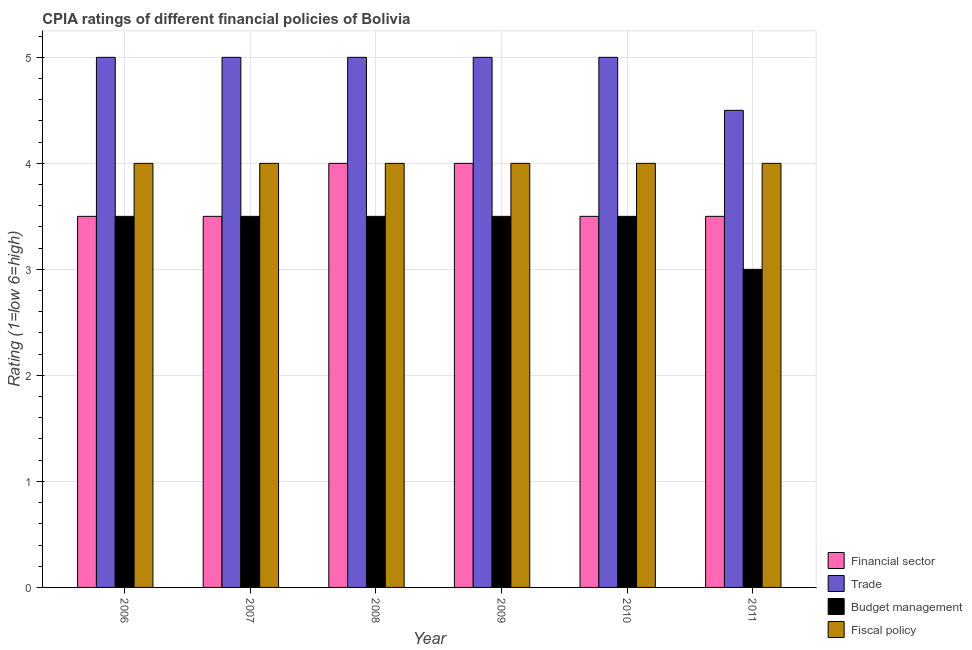Are the number of bars on each tick of the X-axis equal?
Give a very brief answer. Yes. What is the cpia rating of trade in 2007?
Give a very brief answer. 5. Across all years, what is the maximum cpia rating of fiscal policy?
Your response must be concise. 4. Across all years, what is the minimum cpia rating of fiscal policy?
Your response must be concise. 4. What is the total cpia rating of financial sector in the graph?
Give a very brief answer. 22. What is the average cpia rating of budget management per year?
Offer a terse response. 3.42. What is the ratio of the cpia rating of trade in 2008 to that in 2011?
Provide a succinct answer. 1.11. Is the cpia rating of trade in 2006 less than that in 2009?
Your response must be concise. No. Is it the case that in every year, the sum of the cpia rating of trade and cpia rating of budget management is greater than the sum of cpia rating of fiscal policy and cpia rating of financial sector?
Make the answer very short. Yes. What does the 4th bar from the left in 2008 represents?
Keep it short and to the point. Fiscal policy. What does the 1st bar from the right in 2006 represents?
Your answer should be compact. Fiscal policy. Is it the case that in every year, the sum of the cpia rating of financial sector and cpia rating of trade is greater than the cpia rating of budget management?
Ensure brevity in your answer.  Yes. How many bars are there?
Your answer should be compact. 24. Are all the bars in the graph horizontal?
Ensure brevity in your answer.  No. How many years are there in the graph?
Your answer should be compact. 6. What is the difference between two consecutive major ticks on the Y-axis?
Provide a short and direct response. 1. Does the graph contain any zero values?
Offer a terse response. No. Does the graph contain grids?
Ensure brevity in your answer.  Yes. How many legend labels are there?
Your answer should be compact. 4. How are the legend labels stacked?
Provide a succinct answer. Vertical. What is the title of the graph?
Provide a short and direct response. CPIA ratings of different financial policies of Bolivia. Does "Burnt food" appear as one of the legend labels in the graph?
Ensure brevity in your answer.  No. What is the label or title of the Y-axis?
Provide a short and direct response. Rating (1=low 6=high). What is the Rating (1=low 6=high) of Trade in 2006?
Your response must be concise. 5. What is the Rating (1=low 6=high) of Fiscal policy in 2006?
Provide a succinct answer. 4. What is the Rating (1=low 6=high) of Trade in 2007?
Make the answer very short. 5. What is the Rating (1=low 6=high) in Budget management in 2007?
Your answer should be compact. 3.5. What is the Rating (1=low 6=high) in Fiscal policy in 2007?
Ensure brevity in your answer.  4. What is the Rating (1=low 6=high) in Financial sector in 2008?
Your response must be concise. 4. What is the Rating (1=low 6=high) of Trade in 2008?
Your answer should be very brief. 5. What is the Rating (1=low 6=high) of Fiscal policy in 2008?
Provide a succinct answer. 4. What is the Rating (1=low 6=high) in Trade in 2010?
Your answer should be compact. 5. What is the Rating (1=low 6=high) of Budget management in 2010?
Offer a very short reply. 3.5. What is the Rating (1=low 6=high) in Fiscal policy in 2010?
Your answer should be compact. 4. What is the Rating (1=low 6=high) of Financial sector in 2011?
Your answer should be compact. 3.5. What is the Rating (1=low 6=high) of Trade in 2011?
Provide a short and direct response. 4.5. What is the Rating (1=low 6=high) of Budget management in 2011?
Your response must be concise. 3. What is the Rating (1=low 6=high) in Fiscal policy in 2011?
Your response must be concise. 4. Across all years, what is the maximum Rating (1=low 6=high) of Budget management?
Make the answer very short. 3.5. Across all years, what is the minimum Rating (1=low 6=high) in Budget management?
Keep it short and to the point. 3. Across all years, what is the minimum Rating (1=low 6=high) in Fiscal policy?
Keep it short and to the point. 4. What is the total Rating (1=low 6=high) of Trade in the graph?
Provide a short and direct response. 29.5. What is the difference between the Rating (1=low 6=high) in Trade in 2006 and that in 2008?
Give a very brief answer. 0. What is the difference between the Rating (1=low 6=high) in Fiscal policy in 2006 and that in 2008?
Your answer should be very brief. 0. What is the difference between the Rating (1=low 6=high) of Budget management in 2006 and that in 2009?
Give a very brief answer. 0. What is the difference between the Rating (1=low 6=high) in Fiscal policy in 2006 and that in 2009?
Ensure brevity in your answer.  0. What is the difference between the Rating (1=low 6=high) of Financial sector in 2006 and that in 2010?
Offer a very short reply. 0. What is the difference between the Rating (1=low 6=high) in Budget management in 2006 and that in 2010?
Ensure brevity in your answer.  0. What is the difference between the Rating (1=low 6=high) in Fiscal policy in 2006 and that in 2010?
Provide a short and direct response. 0. What is the difference between the Rating (1=low 6=high) in Financial sector in 2006 and that in 2011?
Your answer should be compact. 0. What is the difference between the Rating (1=low 6=high) in Fiscal policy in 2006 and that in 2011?
Offer a very short reply. 0. What is the difference between the Rating (1=low 6=high) in Budget management in 2007 and that in 2008?
Provide a succinct answer. 0. What is the difference between the Rating (1=low 6=high) of Fiscal policy in 2007 and that in 2008?
Make the answer very short. 0. What is the difference between the Rating (1=low 6=high) of Financial sector in 2007 and that in 2009?
Provide a succinct answer. -0.5. What is the difference between the Rating (1=low 6=high) in Fiscal policy in 2007 and that in 2009?
Give a very brief answer. 0. What is the difference between the Rating (1=low 6=high) of Fiscal policy in 2007 and that in 2010?
Keep it short and to the point. 0. What is the difference between the Rating (1=low 6=high) of Trade in 2007 and that in 2011?
Offer a terse response. 0.5. What is the difference between the Rating (1=low 6=high) of Budget management in 2007 and that in 2011?
Offer a terse response. 0.5. What is the difference between the Rating (1=low 6=high) of Fiscal policy in 2007 and that in 2011?
Provide a succinct answer. 0. What is the difference between the Rating (1=low 6=high) of Trade in 2008 and that in 2009?
Ensure brevity in your answer.  0. What is the difference between the Rating (1=low 6=high) in Financial sector in 2008 and that in 2010?
Give a very brief answer. 0.5. What is the difference between the Rating (1=low 6=high) of Budget management in 2008 and that in 2010?
Offer a terse response. 0. What is the difference between the Rating (1=low 6=high) in Fiscal policy in 2008 and that in 2010?
Keep it short and to the point. 0. What is the difference between the Rating (1=low 6=high) in Financial sector in 2008 and that in 2011?
Provide a succinct answer. 0.5. What is the difference between the Rating (1=low 6=high) in Financial sector in 2009 and that in 2011?
Provide a succinct answer. 0.5. What is the difference between the Rating (1=low 6=high) of Budget management in 2009 and that in 2011?
Your response must be concise. 0.5. What is the difference between the Rating (1=low 6=high) of Fiscal policy in 2009 and that in 2011?
Provide a succinct answer. 0. What is the difference between the Rating (1=low 6=high) in Financial sector in 2010 and that in 2011?
Give a very brief answer. 0. What is the difference between the Rating (1=low 6=high) in Trade in 2010 and that in 2011?
Offer a terse response. 0.5. What is the difference between the Rating (1=low 6=high) in Budget management in 2010 and that in 2011?
Offer a terse response. 0.5. What is the difference between the Rating (1=low 6=high) in Financial sector in 2006 and the Rating (1=low 6=high) in Budget management in 2007?
Ensure brevity in your answer.  0. What is the difference between the Rating (1=low 6=high) of Financial sector in 2006 and the Rating (1=low 6=high) of Fiscal policy in 2007?
Give a very brief answer. -0.5. What is the difference between the Rating (1=low 6=high) of Trade in 2006 and the Rating (1=low 6=high) of Budget management in 2007?
Provide a short and direct response. 1.5. What is the difference between the Rating (1=low 6=high) in Budget management in 2006 and the Rating (1=low 6=high) in Fiscal policy in 2007?
Offer a very short reply. -0.5. What is the difference between the Rating (1=low 6=high) in Trade in 2006 and the Rating (1=low 6=high) in Fiscal policy in 2008?
Keep it short and to the point. 1. What is the difference between the Rating (1=low 6=high) of Budget management in 2006 and the Rating (1=low 6=high) of Fiscal policy in 2008?
Provide a short and direct response. -0.5. What is the difference between the Rating (1=low 6=high) in Financial sector in 2006 and the Rating (1=low 6=high) in Trade in 2009?
Your answer should be very brief. -1.5. What is the difference between the Rating (1=low 6=high) in Financial sector in 2006 and the Rating (1=low 6=high) in Budget management in 2009?
Your response must be concise. 0. What is the difference between the Rating (1=low 6=high) of Financial sector in 2006 and the Rating (1=low 6=high) of Fiscal policy in 2009?
Give a very brief answer. -0.5. What is the difference between the Rating (1=low 6=high) in Trade in 2006 and the Rating (1=low 6=high) in Fiscal policy in 2009?
Give a very brief answer. 1. What is the difference between the Rating (1=low 6=high) of Budget management in 2006 and the Rating (1=low 6=high) of Fiscal policy in 2009?
Your answer should be compact. -0.5. What is the difference between the Rating (1=low 6=high) of Financial sector in 2006 and the Rating (1=low 6=high) of Trade in 2010?
Provide a succinct answer. -1.5. What is the difference between the Rating (1=low 6=high) in Financial sector in 2006 and the Rating (1=low 6=high) in Fiscal policy in 2010?
Give a very brief answer. -0.5. What is the difference between the Rating (1=low 6=high) of Trade in 2006 and the Rating (1=low 6=high) of Budget management in 2010?
Offer a very short reply. 1.5. What is the difference between the Rating (1=low 6=high) in Trade in 2006 and the Rating (1=low 6=high) in Fiscal policy in 2010?
Ensure brevity in your answer.  1. What is the difference between the Rating (1=low 6=high) of Financial sector in 2006 and the Rating (1=low 6=high) of Trade in 2011?
Offer a terse response. -1. What is the difference between the Rating (1=low 6=high) in Financial sector in 2006 and the Rating (1=low 6=high) in Budget management in 2011?
Give a very brief answer. 0.5. What is the difference between the Rating (1=low 6=high) of Financial sector in 2007 and the Rating (1=low 6=high) of Budget management in 2008?
Make the answer very short. 0. What is the difference between the Rating (1=low 6=high) of Trade in 2007 and the Rating (1=low 6=high) of Budget management in 2008?
Offer a very short reply. 1.5. What is the difference between the Rating (1=low 6=high) in Trade in 2007 and the Rating (1=low 6=high) in Fiscal policy in 2008?
Give a very brief answer. 1. What is the difference between the Rating (1=low 6=high) of Budget management in 2007 and the Rating (1=low 6=high) of Fiscal policy in 2008?
Offer a very short reply. -0.5. What is the difference between the Rating (1=low 6=high) in Financial sector in 2007 and the Rating (1=low 6=high) in Trade in 2009?
Provide a short and direct response. -1.5. What is the difference between the Rating (1=low 6=high) of Financial sector in 2007 and the Rating (1=low 6=high) of Budget management in 2009?
Your answer should be very brief. 0. What is the difference between the Rating (1=low 6=high) in Financial sector in 2007 and the Rating (1=low 6=high) in Fiscal policy in 2009?
Keep it short and to the point. -0.5. What is the difference between the Rating (1=low 6=high) of Budget management in 2007 and the Rating (1=low 6=high) of Fiscal policy in 2009?
Ensure brevity in your answer.  -0.5. What is the difference between the Rating (1=low 6=high) in Financial sector in 2007 and the Rating (1=low 6=high) in Budget management in 2010?
Offer a very short reply. 0. What is the difference between the Rating (1=low 6=high) of Financial sector in 2007 and the Rating (1=low 6=high) of Trade in 2011?
Give a very brief answer. -1. What is the difference between the Rating (1=low 6=high) of Trade in 2007 and the Rating (1=low 6=high) of Budget management in 2011?
Ensure brevity in your answer.  2. What is the difference between the Rating (1=low 6=high) in Budget management in 2007 and the Rating (1=low 6=high) in Fiscal policy in 2011?
Your answer should be compact. -0.5. What is the difference between the Rating (1=low 6=high) of Financial sector in 2008 and the Rating (1=low 6=high) of Fiscal policy in 2009?
Your answer should be very brief. 0. What is the difference between the Rating (1=low 6=high) of Trade in 2008 and the Rating (1=low 6=high) of Fiscal policy in 2009?
Your response must be concise. 1. What is the difference between the Rating (1=low 6=high) of Trade in 2008 and the Rating (1=low 6=high) of Budget management in 2010?
Your response must be concise. 1.5. What is the difference between the Rating (1=low 6=high) of Budget management in 2008 and the Rating (1=low 6=high) of Fiscal policy in 2010?
Your answer should be compact. -0.5. What is the difference between the Rating (1=low 6=high) of Financial sector in 2008 and the Rating (1=low 6=high) of Trade in 2011?
Provide a succinct answer. -0.5. What is the difference between the Rating (1=low 6=high) of Financial sector in 2008 and the Rating (1=low 6=high) of Budget management in 2011?
Your response must be concise. 1. What is the difference between the Rating (1=low 6=high) of Trade in 2008 and the Rating (1=low 6=high) of Budget management in 2011?
Make the answer very short. 2. What is the difference between the Rating (1=low 6=high) of Trade in 2008 and the Rating (1=low 6=high) of Fiscal policy in 2011?
Offer a terse response. 1. What is the difference between the Rating (1=low 6=high) of Trade in 2009 and the Rating (1=low 6=high) of Budget management in 2010?
Provide a short and direct response. 1.5. What is the difference between the Rating (1=low 6=high) in Budget management in 2009 and the Rating (1=low 6=high) in Fiscal policy in 2010?
Keep it short and to the point. -0.5. What is the difference between the Rating (1=low 6=high) of Financial sector in 2009 and the Rating (1=low 6=high) of Budget management in 2011?
Ensure brevity in your answer.  1. What is the difference between the Rating (1=low 6=high) in Financial sector in 2009 and the Rating (1=low 6=high) in Fiscal policy in 2011?
Your answer should be very brief. 0. What is the difference between the Rating (1=low 6=high) in Financial sector in 2010 and the Rating (1=low 6=high) in Budget management in 2011?
Offer a terse response. 0.5. What is the difference between the Rating (1=low 6=high) of Financial sector in 2010 and the Rating (1=low 6=high) of Fiscal policy in 2011?
Your answer should be compact. -0.5. What is the difference between the Rating (1=low 6=high) in Trade in 2010 and the Rating (1=low 6=high) in Fiscal policy in 2011?
Your response must be concise. 1. What is the difference between the Rating (1=low 6=high) of Budget management in 2010 and the Rating (1=low 6=high) of Fiscal policy in 2011?
Provide a succinct answer. -0.5. What is the average Rating (1=low 6=high) in Financial sector per year?
Offer a terse response. 3.67. What is the average Rating (1=low 6=high) of Trade per year?
Give a very brief answer. 4.92. What is the average Rating (1=low 6=high) of Budget management per year?
Keep it short and to the point. 3.42. What is the average Rating (1=low 6=high) of Fiscal policy per year?
Offer a terse response. 4. In the year 2006, what is the difference between the Rating (1=low 6=high) in Financial sector and Rating (1=low 6=high) in Trade?
Keep it short and to the point. -1.5. In the year 2006, what is the difference between the Rating (1=low 6=high) of Financial sector and Rating (1=low 6=high) of Budget management?
Keep it short and to the point. 0. In the year 2006, what is the difference between the Rating (1=low 6=high) of Trade and Rating (1=low 6=high) of Budget management?
Provide a succinct answer. 1.5. In the year 2006, what is the difference between the Rating (1=low 6=high) of Trade and Rating (1=low 6=high) of Fiscal policy?
Offer a very short reply. 1. In the year 2006, what is the difference between the Rating (1=low 6=high) in Budget management and Rating (1=low 6=high) in Fiscal policy?
Provide a short and direct response. -0.5. In the year 2007, what is the difference between the Rating (1=low 6=high) in Financial sector and Rating (1=low 6=high) in Fiscal policy?
Offer a very short reply. -0.5. In the year 2008, what is the difference between the Rating (1=low 6=high) in Financial sector and Rating (1=low 6=high) in Trade?
Ensure brevity in your answer.  -1. In the year 2008, what is the difference between the Rating (1=low 6=high) of Financial sector and Rating (1=low 6=high) of Budget management?
Give a very brief answer. 0.5. In the year 2008, what is the difference between the Rating (1=low 6=high) in Financial sector and Rating (1=low 6=high) in Fiscal policy?
Your response must be concise. 0. In the year 2008, what is the difference between the Rating (1=low 6=high) in Trade and Rating (1=low 6=high) in Budget management?
Your response must be concise. 1.5. In the year 2008, what is the difference between the Rating (1=low 6=high) of Trade and Rating (1=low 6=high) of Fiscal policy?
Ensure brevity in your answer.  1. In the year 2009, what is the difference between the Rating (1=low 6=high) of Trade and Rating (1=low 6=high) of Budget management?
Make the answer very short. 1.5. In the year 2009, what is the difference between the Rating (1=low 6=high) in Budget management and Rating (1=low 6=high) in Fiscal policy?
Your answer should be compact. -0.5. In the year 2010, what is the difference between the Rating (1=low 6=high) in Trade and Rating (1=low 6=high) in Budget management?
Your response must be concise. 1.5. In the year 2010, what is the difference between the Rating (1=low 6=high) in Trade and Rating (1=low 6=high) in Fiscal policy?
Provide a short and direct response. 1. In the year 2010, what is the difference between the Rating (1=low 6=high) of Budget management and Rating (1=low 6=high) of Fiscal policy?
Make the answer very short. -0.5. In the year 2011, what is the difference between the Rating (1=low 6=high) of Trade and Rating (1=low 6=high) of Fiscal policy?
Your answer should be compact. 0.5. In the year 2011, what is the difference between the Rating (1=low 6=high) of Budget management and Rating (1=low 6=high) of Fiscal policy?
Make the answer very short. -1. What is the ratio of the Rating (1=low 6=high) in Financial sector in 2006 to that in 2007?
Offer a terse response. 1. What is the ratio of the Rating (1=low 6=high) in Trade in 2006 to that in 2007?
Offer a terse response. 1. What is the ratio of the Rating (1=low 6=high) of Budget management in 2006 to that in 2007?
Ensure brevity in your answer.  1. What is the ratio of the Rating (1=low 6=high) of Financial sector in 2006 to that in 2008?
Ensure brevity in your answer.  0.88. What is the ratio of the Rating (1=low 6=high) in Trade in 2006 to that in 2008?
Give a very brief answer. 1. What is the ratio of the Rating (1=low 6=high) of Fiscal policy in 2006 to that in 2008?
Provide a short and direct response. 1. What is the ratio of the Rating (1=low 6=high) of Financial sector in 2006 to that in 2009?
Your answer should be compact. 0.88. What is the ratio of the Rating (1=low 6=high) of Budget management in 2006 to that in 2009?
Your answer should be compact. 1. What is the ratio of the Rating (1=low 6=high) in Budget management in 2006 to that in 2010?
Provide a succinct answer. 1. What is the ratio of the Rating (1=low 6=high) of Financial sector in 2006 to that in 2011?
Your answer should be compact. 1. What is the ratio of the Rating (1=low 6=high) in Budget management in 2006 to that in 2011?
Your answer should be compact. 1.17. What is the ratio of the Rating (1=low 6=high) in Budget management in 2007 to that in 2008?
Give a very brief answer. 1. What is the ratio of the Rating (1=low 6=high) of Budget management in 2007 to that in 2009?
Offer a very short reply. 1. What is the ratio of the Rating (1=low 6=high) of Fiscal policy in 2007 to that in 2009?
Your response must be concise. 1. What is the ratio of the Rating (1=low 6=high) in Financial sector in 2007 to that in 2010?
Ensure brevity in your answer.  1. What is the ratio of the Rating (1=low 6=high) in Budget management in 2007 to that in 2010?
Your answer should be very brief. 1. What is the ratio of the Rating (1=low 6=high) of Fiscal policy in 2007 to that in 2010?
Make the answer very short. 1. What is the ratio of the Rating (1=low 6=high) in Financial sector in 2007 to that in 2011?
Provide a succinct answer. 1. What is the ratio of the Rating (1=low 6=high) of Trade in 2007 to that in 2011?
Your answer should be compact. 1.11. What is the ratio of the Rating (1=low 6=high) in Financial sector in 2008 to that in 2009?
Your answer should be very brief. 1. What is the ratio of the Rating (1=low 6=high) in Budget management in 2008 to that in 2009?
Provide a succinct answer. 1. What is the ratio of the Rating (1=low 6=high) in Fiscal policy in 2008 to that in 2009?
Offer a terse response. 1. What is the ratio of the Rating (1=low 6=high) of Financial sector in 2008 to that in 2010?
Your answer should be very brief. 1.14. What is the ratio of the Rating (1=low 6=high) of Trade in 2008 to that in 2010?
Give a very brief answer. 1. What is the ratio of the Rating (1=low 6=high) in Budget management in 2008 to that in 2010?
Your answer should be very brief. 1. What is the ratio of the Rating (1=low 6=high) of Fiscal policy in 2008 to that in 2010?
Offer a very short reply. 1. What is the ratio of the Rating (1=low 6=high) of Trade in 2008 to that in 2011?
Ensure brevity in your answer.  1.11. What is the ratio of the Rating (1=low 6=high) of Budget management in 2009 to that in 2010?
Your response must be concise. 1. What is the ratio of the Rating (1=low 6=high) in Trade in 2009 to that in 2011?
Ensure brevity in your answer.  1.11. What is the ratio of the Rating (1=low 6=high) of Budget management in 2009 to that in 2011?
Give a very brief answer. 1.17. What is the ratio of the Rating (1=low 6=high) in Financial sector in 2010 to that in 2011?
Your response must be concise. 1. What is the ratio of the Rating (1=low 6=high) of Budget management in 2010 to that in 2011?
Ensure brevity in your answer.  1.17. What is the ratio of the Rating (1=low 6=high) in Fiscal policy in 2010 to that in 2011?
Your answer should be very brief. 1. What is the difference between the highest and the second highest Rating (1=low 6=high) in Financial sector?
Your answer should be very brief. 0. What is the difference between the highest and the lowest Rating (1=low 6=high) in Financial sector?
Your answer should be compact. 0.5. What is the difference between the highest and the lowest Rating (1=low 6=high) in Trade?
Make the answer very short. 0.5. What is the difference between the highest and the lowest Rating (1=low 6=high) of Budget management?
Your answer should be compact. 0.5. What is the difference between the highest and the lowest Rating (1=low 6=high) of Fiscal policy?
Your response must be concise. 0. 